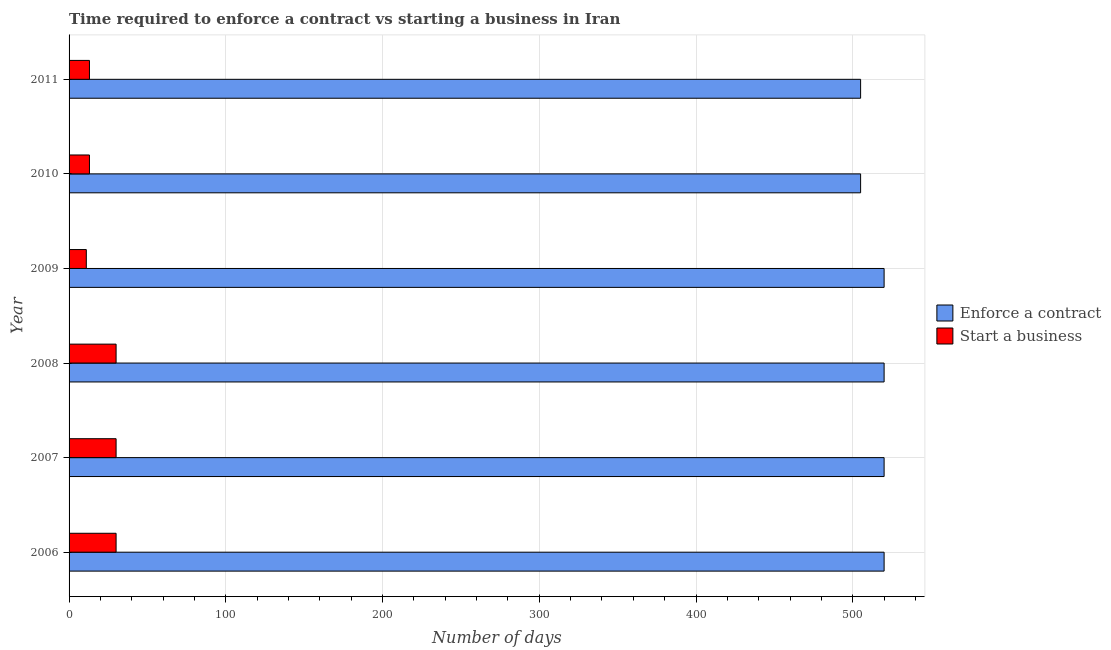How many groups of bars are there?
Your answer should be compact. 6. How many bars are there on the 2nd tick from the top?
Your answer should be very brief. 2. How many bars are there on the 5th tick from the bottom?
Provide a succinct answer. 2. What is the label of the 4th group of bars from the top?
Your answer should be compact. 2008. In how many cases, is the number of bars for a given year not equal to the number of legend labels?
Keep it short and to the point. 0. What is the number of days to enforece a contract in 2008?
Provide a short and direct response. 520. Across all years, what is the maximum number of days to enforece a contract?
Offer a very short reply. 520. Across all years, what is the minimum number of days to start a business?
Your response must be concise. 11. In which year was the number of days to enforece a contract maximum?
Provide a succinct answer. 2006. In which year was the number of days to enforece a contract minimum?
Your response must be concise. 2010. What is the total number of days to start a business in the graph?
Your answer should be very brief. 127. What is the difference between the number of days to start a business in 2007 and that in 2010?
Your answer should be very brief. 17. What is the difference between the number of days to enforece a contract in 2010 and the number of days to start a business in 2011?
Your response must be concise. 492. What is the average number of days to start a business per year?
Provide a succinct answer. 21.17. In the year 2009, what is the difference between the number of days to start a business and number of days to enforece a contract?
Provide a short and direct response. -509. In how many years, is the number of days to start a business greater than 240 days?
Give a very brief answer. 0. Is the number of days to start a business in 2007 less than that in 2011?
Your answer should be very brief. No. Is the difference between the number of days to enforece a contract in 2007 and 2011 greater than the difference between the number of days to start a business in 2007 and 2011?
Give a very brief answer. No. What is the difference between the highest and the lowest number of days to enforece a contract?
Make the answer very short. 15. In how many years, is the number of days to start a business greater than the average number of days to start a business taken over all years?
Your response must be concise. 3. Is the sum of the number of days to start a business in 2009 and 2011 greater than the maximum number of days to enforece a contract across all years?
Provide a short and direct response. No. What does the 1st bar from the top in 2011 represents?
Provide a succinct answer. Start a business. What does the 2nd bar from the bottom in 2009 represents?
Your answer should be very brief. Start a business. Are all the bars in the graph horizontal?
Offer a very short reply. Yes. What is the difference between two consecutive major ticks on the X-axis?
Make the answer very short. 100. Are the values on the major ticks of X-axis written in scientific E-notation?
Give a very brief answer. No. Where does the legend appear in the graph?
Give a very brief answer. Center right. How many legend labels are there?
Your answer should be very brief. 2. How are the legend labels stacked?
Keep it short and to the point. Vertical. What is the title of the graph?
Your response must be concise. Time required to enforce a contract vs starting a business in Iran. What is the label or title of the X-axis?
Your answer should be very brief. Number of days. What is the Number of days of Enforce a contract in 2006?
Make the answer very short. 520. What is the Number of days of Start a business in 2006?
Keep it short and to the point. 30. What is the Number of days of Enforce a contract in 2007?
Offer a terse response. 520. What is the Number of days of Start a business in 2007?
Provide a short and direct response. 30. What is the Number of days in Enforce a contract in 2008?
Offer a very short reply. 520. What is the Number of days of Enforce a contract in 2009?
Your answer should be compact. 520. What is the Number of days of Enforce a contract in 2010?
Your answer should be compact. 505. What is the Number of days of Enforce a contract in 2011?
Your answer should be very brief. 505. Across all years, what is the maximum Number of days of Enforce a contract?
Your response must be concise. 520. Across all years, what is the maximum Number of days in Start a business?
Give a very brief answer. 30. Across all years, what is the minimum Number of days of Enforce a contract?
Your answer should be very brief. 505. What is the total Number of days of Enforce a contract in the graph?
Offer a very short reply. 3090. What is the total Number of days of Start a business in the graph?
Offer a terse response. 127. What is the difference between the Number of days of Enforce a contract in 2006 and that in 2009?
Provide a succinct answer. 0. What is the difference between the Number of days of Enforce a contract in 2006 and that in 2010?
Provide a short and direct response. 15. What is the difference between the Number of days in Enforce a contract in 2007 and that in 2009?
Keep it short and to the point. 0. What is the difference between the Number of days in Start a business in 2007 and that in 2009?
Your answer should be compact. 19. What is the difference between the Number of days of Start a business in 2007 and that in 2010?
Ensure brevity in your answer.  17. What is the difference between the Number of days of Enforce a contract in 2007 and that in 2011?
Give a very brief answer. 15. What is the difference between the Number of days in Start a business in 2007 and that in 2011?
Your response must be concise. 17. What is the difference between the Number of days in Enforce a contract in 2008 and that in 2009?
Provide a succinct answer. 0. What is the difference between the Number of days in Start a business in 2008 and that in 2010?
Provide a succinct answer. 17. What is the difference between the Number of days of Enforce a contract in 2008 and that in 2011?
Provide a succinct answer. 15. What is the difference between the Number of days of Enforce a contract in 2009 and that in 2010?
Ensure brevity in your answer.  15. What is the difference between the Number of days in Start a business in 2009 and that in 2010?
Give a very brief answer. -2. What is the difference between the Number of days in Start a business in 2009 and that in 2011?
Your answer should be very brief. -2. What is the difference between the Number of days of Enforce a contract in 2006 and the Number of days of Start a business in 2007?
Give a very brief answer. 490. What is the difference between the Number of days in Enforce a contract in 2006 and the Number of days in Start a business in 2008?
Your response must be concise. 490. What is the difference between the Number of days of Enforce a contract in 2006 and the Number of days of Start a business in 2009?
Your answer should be very brief. 509. What is the difference between the Number of days in Enforce a contract in 2006 and the Number of days in Start a business in 2010?
Make the answer very short. 507. What is the difference between the Number of days of Enforce a contract in 2006 and the Number of days of Start a business in 2011?
Keep it short and to the point. 507. What is the difference between the Number of days of Enforce a contract in 2007 and the Number of days of Start a business in 2008?
Offer a terse response. 490. What is the difference between the Number of days in Enforce a contract in 2007 and the Number of days in Start a business in 2009?
Provide a short and direct response. 509. What is the difference between the Number of days of Enforce a contract in 2007 and the Number of days of Start a business in 2010?
Offer a very short reply. 507. What is the difference between the Number of days in Enforce a contract in 2007 and the Number of days in Start a business in 2011?
Your response must be concise. 507. What is the difference between the Number of days of Enforce a contract in 2008 and the Number of days of Start a business in 2009?
Offer a terse response. 509. What is the difference between the Number of days of Enforce a contract in 2008 and the Number of days of Start a business in 2010?
Your response must be concise. 507. What is the difference between the Number of days in Enforce a contract in 2008 and the Number of days in Start a business in 2011?
Keep it short and to the point. 507. What is the difference between the Number of days in Enforce a contract in 2009 and the Number of days in Start a business in 2010?
Your answer should be compact. 507. What is the difference between the Number of days in Enforce a contract in 2009 and the Number of days in Start a business in 2011?
Your answer should be very brief. 507. What is the difference between the Number of days of Enforce a contract in 2010 and the Number of days of Start a business in 2011?
Give a very brief answer. 492. What is the average Number of days of Enforce a contract per year?
Keep it short and to the point. 515. What is the average Number of days in Start a business per year?
Make the answer very short. 21.17. In the year 2006, what is the difference between the Number of days in Enforce a contract and Number of days in Start a business?
Your answer should be compact. 490. In the year 2007, what is the difference between the Number of days of Enforce a contract and Number of days of Start a business?
Provide a succinct answer. 490. In the year 2008, what is the difference between the Number of days of Enforce a contract and Number of days of Start a business?
Keep it short and to the point. 490. In the year 2009, what is the difference between the Number of days of Enforce a contract and Number of days of Start a business?
Offer a very short reply. 509. In the year 2010, what is the difference between the Number of days in Enforce a contract and Number of days in Start a business?
Provide a short and direct response. 492. In the year 2011, what is the difference between the Number of days of Enforce a contract and Number of days of Start a business?
Your answer should be compact. 492. What is the ratio of the Number of days in Enforce a contract in 2006 to that in 2007?
Keep it short and to the point. 1. What is the ratio of the Number of days of Start a business in 2006 to that in 2007?
Ensure brevity in your answer.  1. What is the ratio of the Number of days of Enforce a contract in 2006 to that in 2008?
Your answer should be very brief. 1. What is the ratio of the Number of days of Enforce a contract in 2006 to that in 2009?
Keep it short and to the point. 1. What is the ratio of the Number of days of Start a business in 2006 to that in 2009?
Provide a short and direct response. 2.73. What is the ratio of the Number of days in Enforce a contract in 2006 to that in 2010?
Your response must be concise. 1.03. What is the ratio of the Number of days of Start a business in 2006 to that in 2010?
Give a very brief answer. 2.31. What is the ratio of the Number of days of Enforce a contract in 2006 to that in 2011?
Keep it short and to the point. 1.03. What is the ratio of the Number of days of Start a business in 2006 to that in 2011?
Offer a terse response. 2.31. What is the ratio of the Number of days of Enforce a contract in 2007 to that in 2008?
Provide a short and direct response. 1. What is the ratio of the Number of days of Start a business in 2007 to that in 2008?
Provide a succinct answer. 1. What is the ratio of the Number of days of Start a business in 2007 to that in 2009?
Offer a very short reply. 2.73. What is the ratio of the Number of days in Enforce a contract in 2007 to that in 2010?
Provide a short and direct response. 1.03. What is the ratio of the Number of days in Start a business in 2007 to that in 2010?
Offer a terse response. 2.31. What is the ratio of the Number of days in Enforce a contract in 2007 to that in 2011?
Ensure brevity in your answer.  1.03. What is the ratio of the Number of days of Start a business in 2007 to that in 2011?
Provide a succinct answer. 2.31. What is the ratio of the Number of days of Start a business in 2008 to that in 2009?
Offer a terse response. 2.73. What is the ratio of the Number of days in Enforce a contract in 2008 to that in 2010?
Your response must be concise. 1.03. What is the ratio of the Number of days of Start a business in 2008 to that in 2010?
Make the answer very short. 2.31. What is the ratio of the Number of days in Enforce a contract in 2008 to that in 2011?
Make the answer very short. 1.03. What is the ratio of the Number of days in Start a business in 2008 to that in 2011?
Offer a terse response. 2.31. What is the ratio of the Number of days of Enforce a contract in 2009 to that in 2010?
Provide a short and direct response. 1.03. What is the ratio of the Number of days of Start a business in 2009 to that in 2010?
Your answer should be very brief. 0.85. What is the ratio of the Number of days of Enforce a contract in 2009 to that in 2011?
Offer a very short reply. 1.03. What is the ratio of the Number of days of Start a business in 2009 to that in 2011?
Give a very brief answer. 0.85. What is the ratio of the Number of days in Start a business in 2010 to that in 2011?
Keep it short and to the point. 1. What is the difference between the highest and the second highest Number of days in Enforce a contract?
Your response must be concise. 0. 